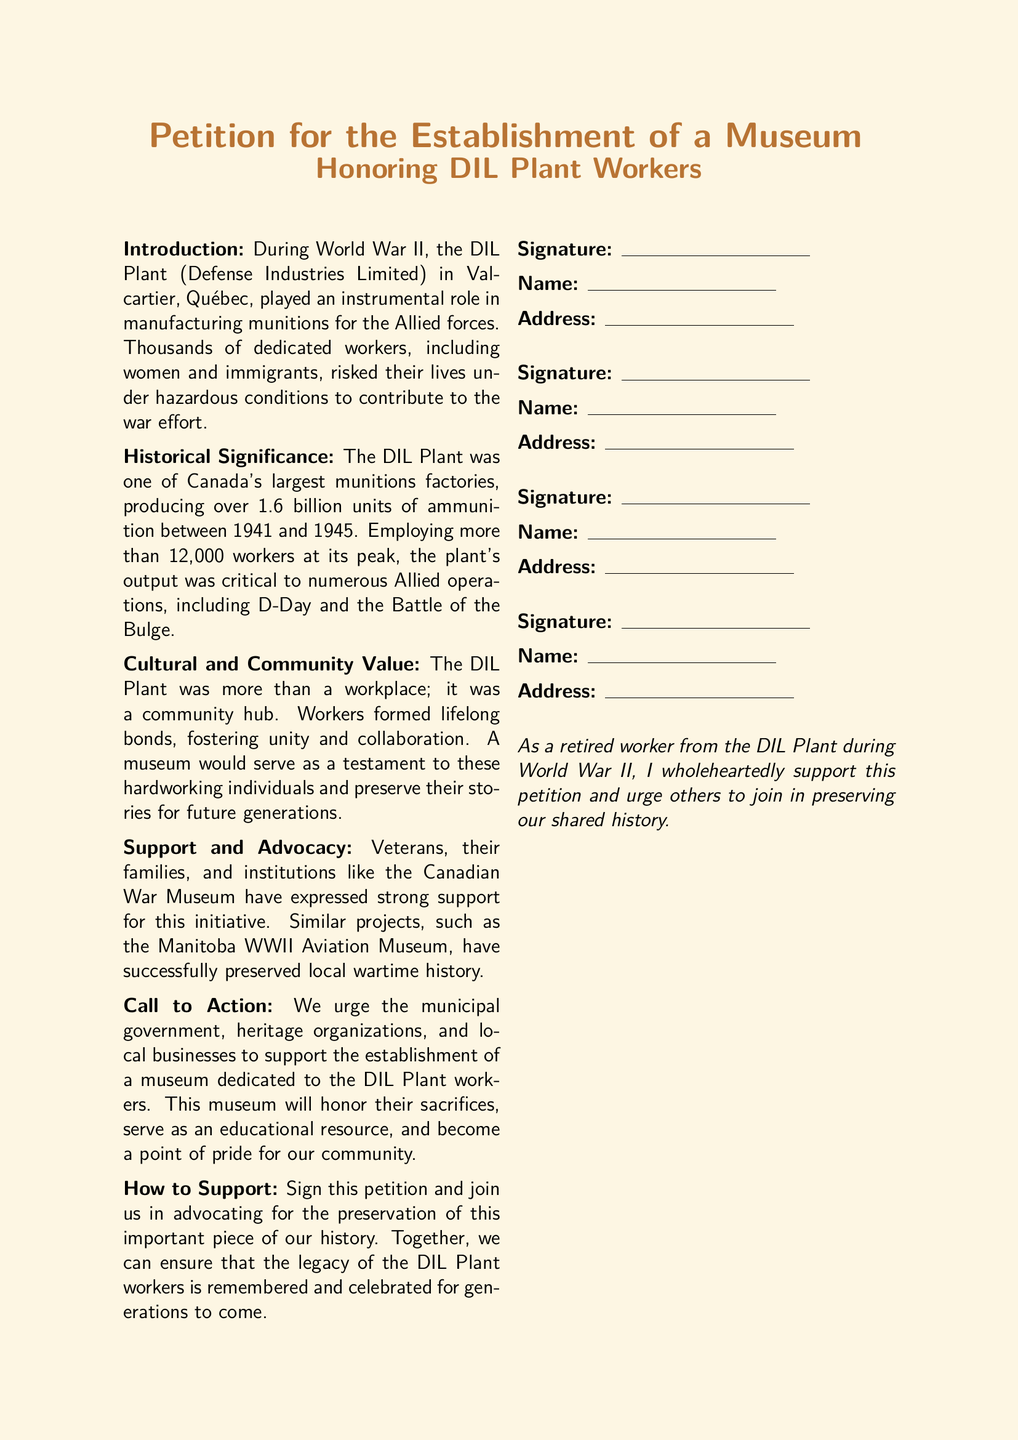what was the primary role of the DIL Plant during World War II? The document states that the DIL Plant played an instrumental role in manufacturing munitions for the Allied forces.
Answer: manufacturing munitions how many units of ammunition did the DIL Plant produce? The document mentions that the DIL Plant produced over 1.6 billion units of ammunition between 1941 and 1945.
Answer: over 1.6 billion what is the peak employment number at the DIL Plant? The document indicates that the plant employed more than 12,000 workers at its peak.
Answer: more than 12,000 who expressed support for the museum initiative? Veterans, their families, and institutions like the Canadian War Museum have expressed strong support for the museum initiative.
Answer: Veterans and families what does the petition urge local organizations to do? The petition urges the municipal government, heritage organizations, and local businesses to support the establishment of a museum dedicated to the DIL Plant workers.
Answer: support the establishment what type of museum is being proposed? The proposed museum is dedicated to honoring DIL Plant workers.
Answer: honoring DIL Plant workers what was the community significance of the DIL Plant as described in the document? The document describes the DIL Plant as a community hub where workers formed lifelong bonds, fostering unity and collaboration.
Answer: community hub how can people participate in supporting the museum establishment? People can participate by signing the petition and advocating for the preservation of the DIL Plant workers' history.
Answer: signing the petition 